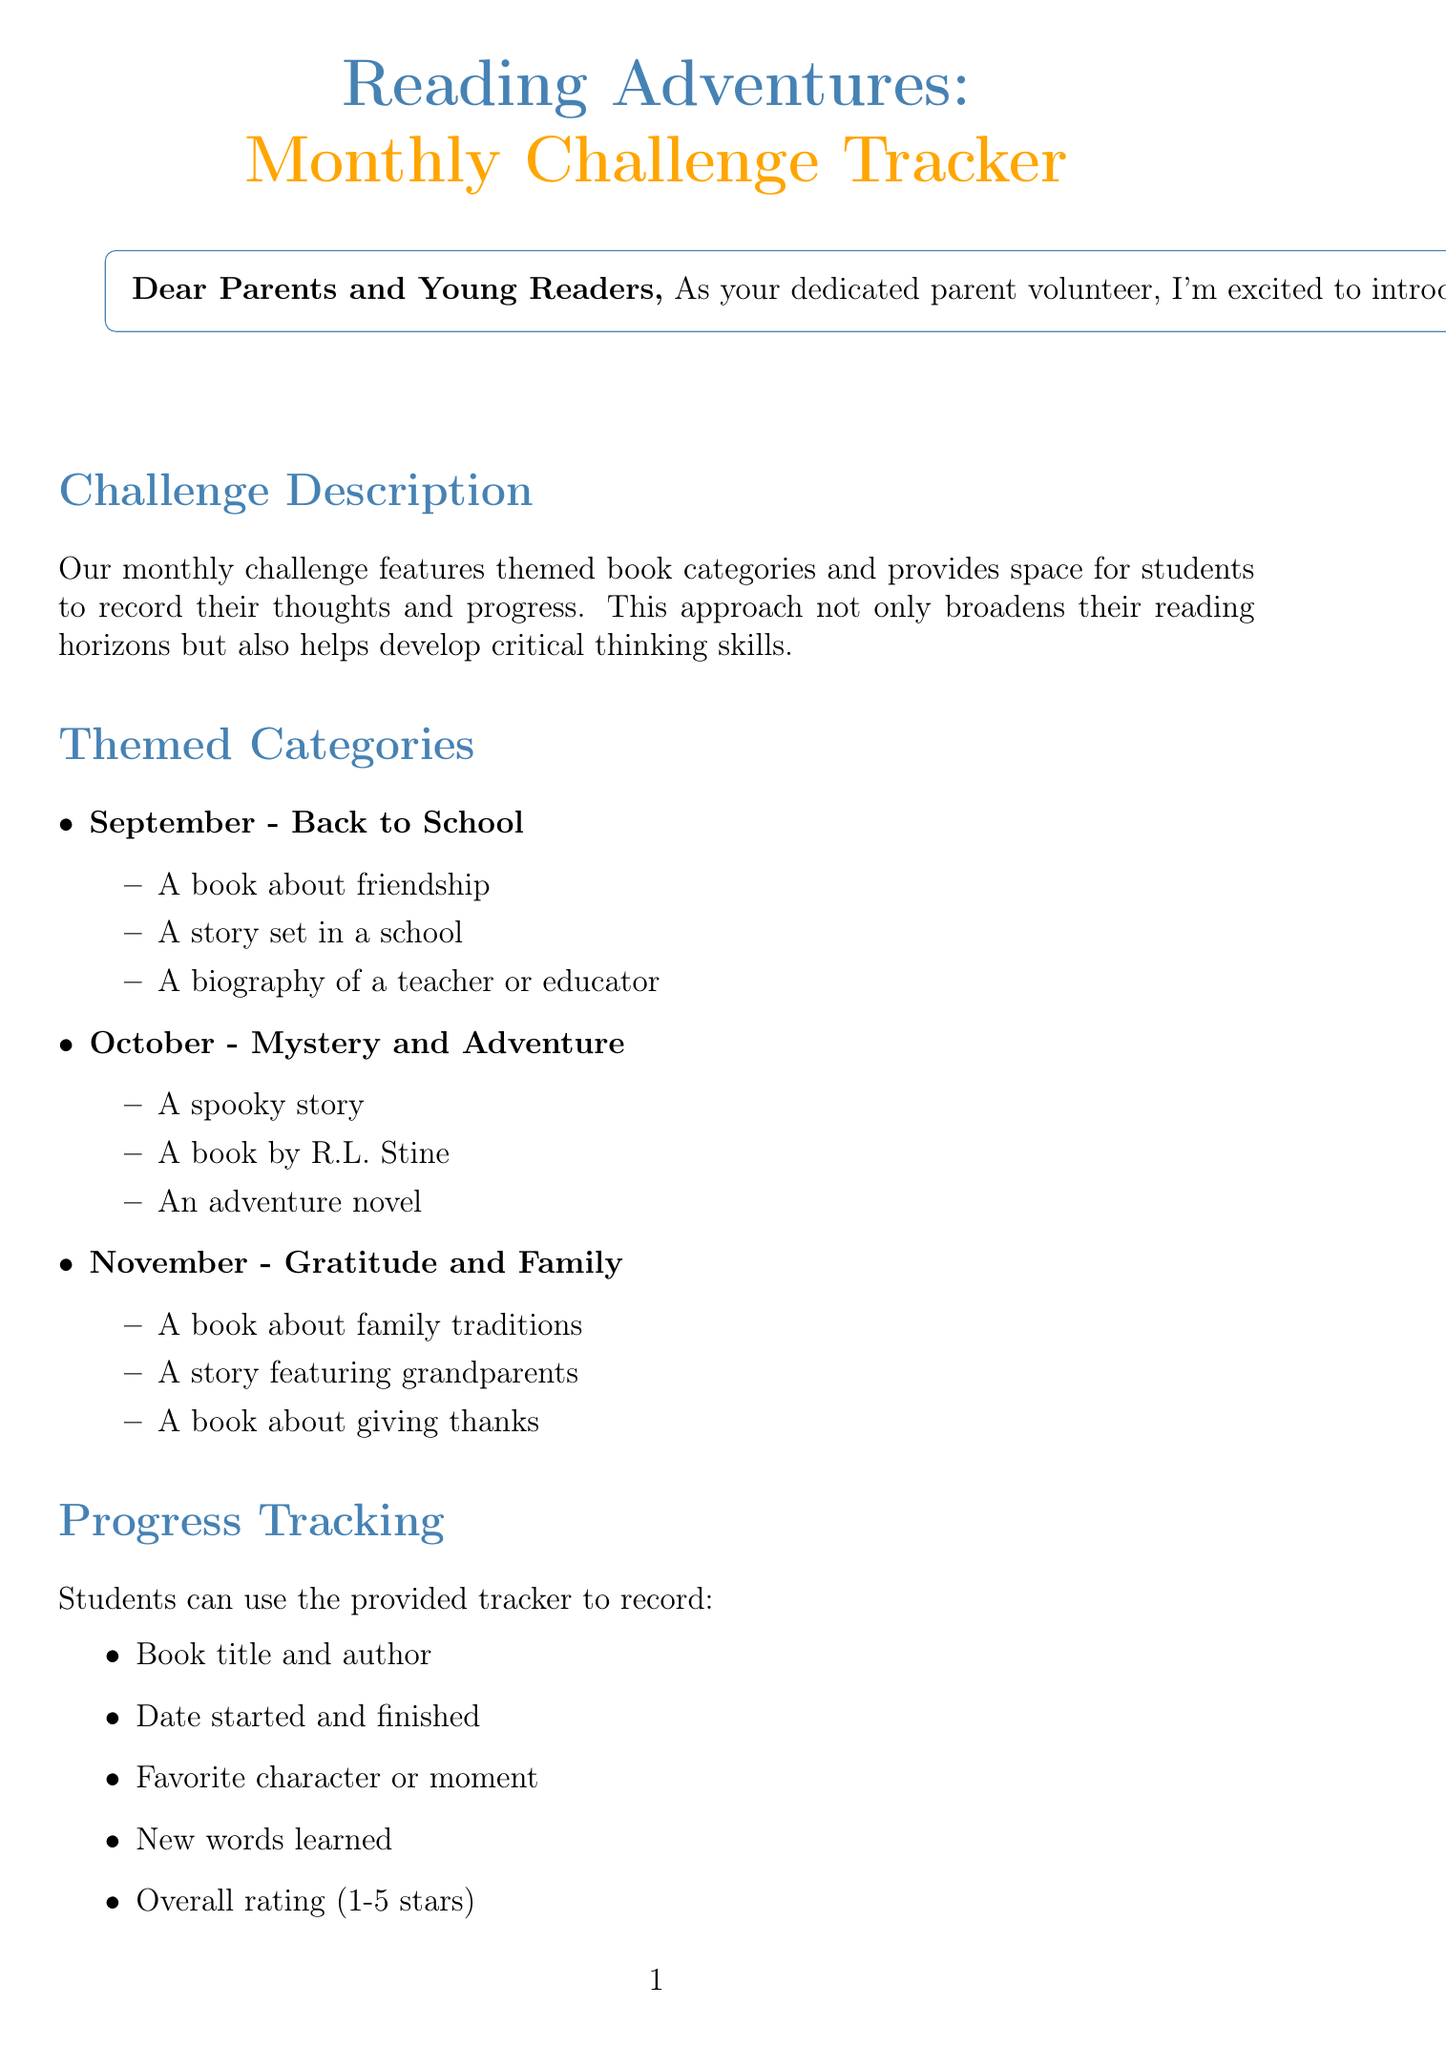what is the title of the newsletter? The title of the newsletter is specified at the beginning and is "Reading Adventures: Monthly Challenge Tracker."
Answer: Reading Adventures: Monthly Challenge Tracker which month is themed "Gratitude and Family"? The themed month for November is described as "Gratitude and Family."
Answer: November what are the three categories for September? The categories listed for September include "A book about friendship," "A story set in a school," and "A biography of a teacher or educator."
Answer: A book about friendship, A story set in a school, A biography of a teacher or educator how many tips are provided for parents? The newsletter enumerates four tips for parents under the section "Parent Tips."
Answer: 4 what is the name of the recommended book by R.J. Palacio? R.J. Palacio is the author of the recommended book titled "Wonder."
Answer: Wonder what type of activity is "Book Bingo"? "Book Bingo" is described as a fun game for students to mark off books they've read in different categories.
Answer: Fun game what information can students record in the tracker? The tracker allows students to record the book title and author, date started and finished, favorite character or moment, new words learned, and overall rating.
Answer: Book title and author, date started and finished, favorite character or moment, new words learned, overall rating who is the contact person for the newsletter? The contact person listed in the newsletter is Sarah Johnson.
Answer: Sarah Johnson 